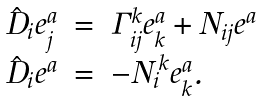<formula> <loc_0><loc_0><loc_500><loc_500>\begin{array} { r c l } \hat { D } _ { i } e ^ { a } _ { j } & = & \Gamma ^ { k } _ { i j } e ^ { a } _ { k } + N _ { i j } e ^ { a } \\ \hat { D } _ { i } e ^ { a } & = & - { N _ { i } } ^ { k } e ^ { a } _ { k } . \end{array}</formula> 